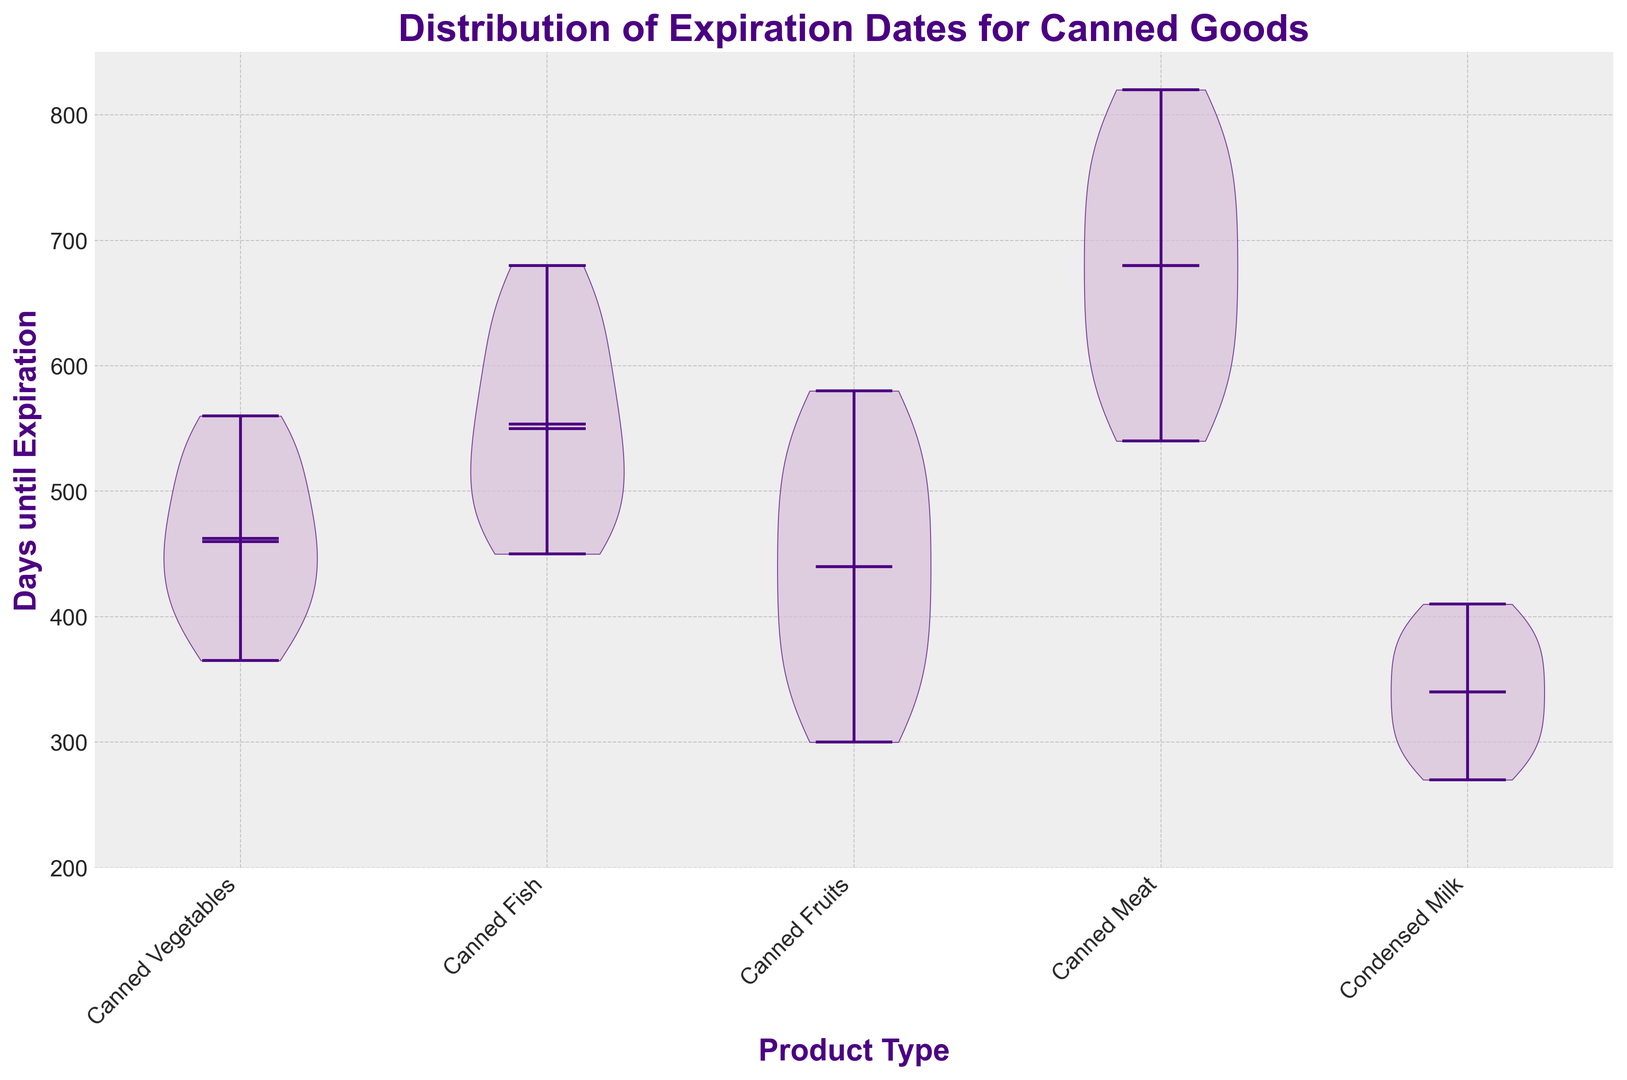What is the median expiration date for canned vegetables? The median is the middle value when the data is ordered. For canned vegetables, the median expiration date is indicated by the horizontal line inside the violin plot.
Answer: 480 Which product type has the highest median expiration date? Compare the positions of the median lines across all violin plots. The product type with the highest median expiration date is the one with the median line highest on the y-axis.
Answer: Canned Meat Do any product types have a median expiration date below 400 days? If so, which ones? Check the positions of the median lines and see if any are located below the 400-day mark on the y-axis.
Answer: Canned Fruits, Condensed Milk What is the interquartile range (IQR) for canned fish? The IQR is the range between the first quartile (25th percentile) and the third quartile (75th percentile). For canned fish, observe the spread in the central part of the violin plot from the bottom quartile to the top quartile.
Answer: 140 days Which product type has the widest range of expiration dates? The width of the range can be identified by looking at the total vertical span of the violin plot for each product type. The one with the widest span has the widest range of expiration dates.
Answer: Canned Meat Do any product types have expiration dates going below 300 days? If so, specify them. Look at the minima of the violin plots and see if any dip below the 300-days mark.
Answer: Canned Fruits, Condensed Milk What's the average expiration date for canned vegetables and canned meat combined? Calculate the mean of expiration dates for both product types. Add up all the expiration days for canned vegetables and canned meat, then divide by the total number of data points in those two categories.
Answer: 591 days Which product type shows the least variability in expiration dates? Variability can be judged by how narrow the spike of the violin plot is. The less spread a plot has, the less variability there is.
Answer: Condensed Milk Compare the highest expiration date of canned fish to the highest expiration date of condensed milk. Which is higher? Check the uppermost points (maximums) of the violin plots for both canned fish and condensed milk.
Answer: Canned Fish What is the maximum expiration date for canned fruits? Identify the topmost point of the violin plot for canned fruits. This represents the maximum expiration date.
Answer: 580 days 